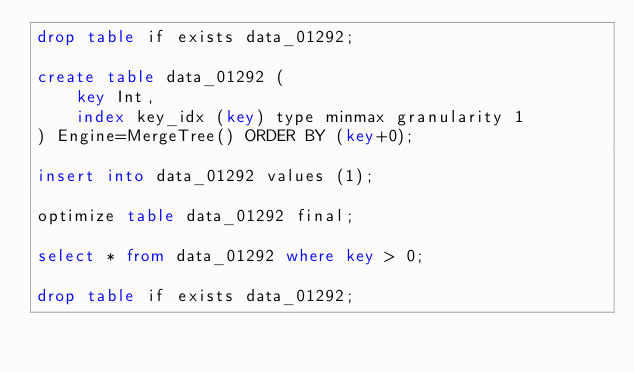<code> <loc_0><loc_0><loc_500><loc_500><_SQL_>drop table if exists data_01292;

create table data_01292 (
    key Int,
    index key_idx (key) type minmax granularity 1
) Engine=MergeTree() ORDER BY (key+0);

insert into data_01292 values (1);

optimize table data_01292 final;

select * from data_01292 where key > 0;

drop table if exists data_01292;
</code> 